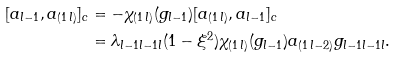<formula> <loc_0><loc_0><loc_500><loc_500>[ a _ { l - 1 } , a _ { ( 1 \, l ) } ] _ { c } & = - \chi _ { ( 1 \, l ) } ( g _ { l - 1 } ) [ a _ { ( 1 \, l ) } , a _ { l - 1 } ] _ { c } \\ & = \lambda _ { l - 1 l - 1 l } ( 1 - \xi ^ { 2 } ) \chi _ { ( 1 \, l ) } ( g _ { l - 1 } ) a _ { ( 1 \, l - 2 ) } g _ { l - 1 l - 1 l } .</formula> 